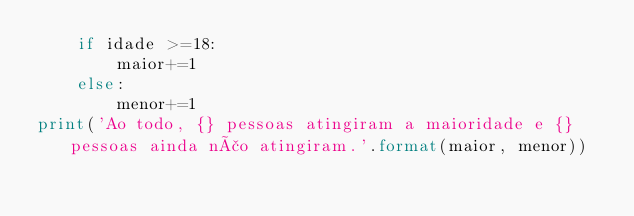Convert code to text. <code><loc_0><loc_0><loc_500><loc_500><_Python_>    if idade >=18:
        maior+=1
    else:
        menor+=1
print('Ao todo, {} pessoas atingiram a maioridade e {} pessoas ainda não atingiram.'.format(maior, menor))
</code> 